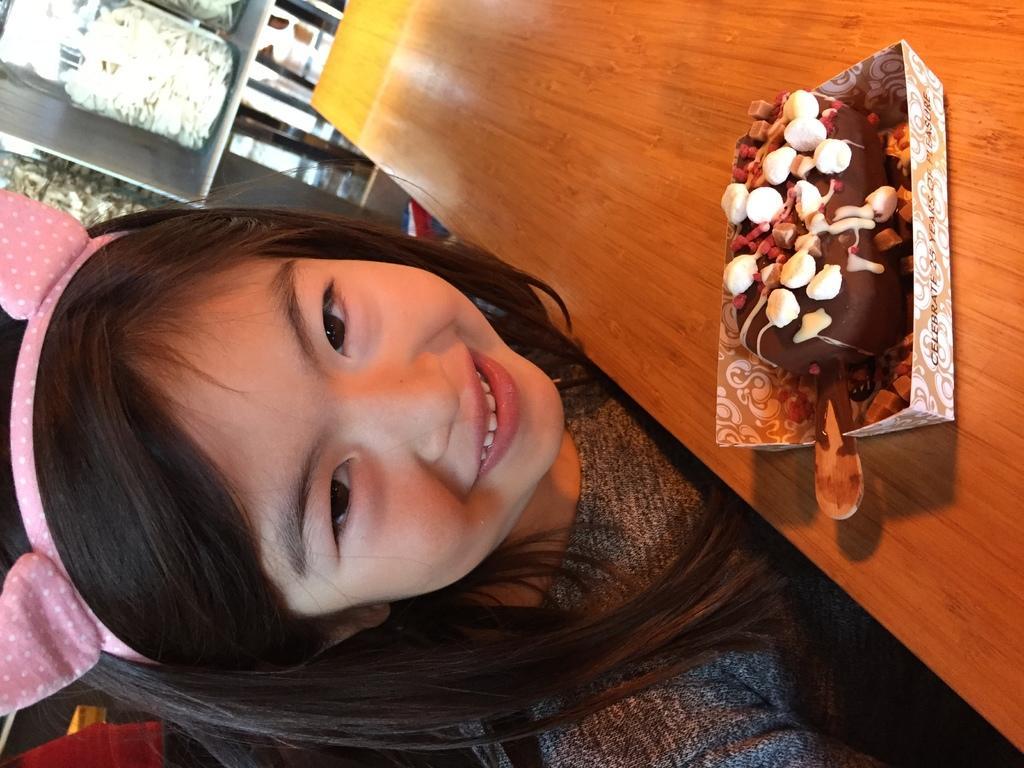Please provide a concise description of this image. In this picture we can see a girl smiling, ice cream in a box and this box is placed on a table and in the background we can see jars. 